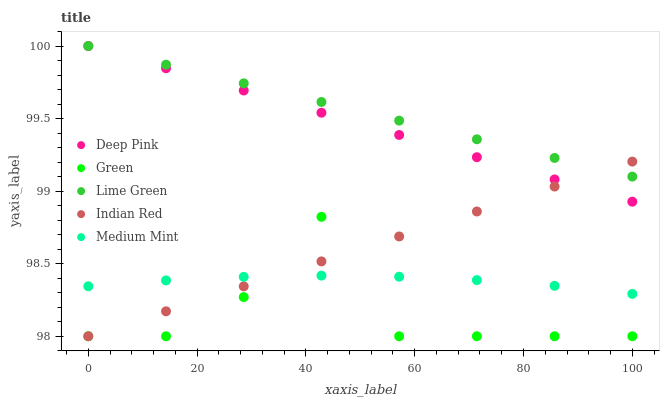Does Green have the minimum area under the curve?
Answer yes or no. Yes. Does Lime Green have the maximum area under the curve?
Answer yes or no. Yes. Does Deep Pink have the minimum area under the curve?
Answer yes or no. No. Does Deep Pink have the maximum area under the curve?
Answer yes or no. No. Is Deep Pink the smoothest?
Answer yes or no. Yes. Is Green the roughest?
Answer yes or no. Yes. Is Lime Green the smoothest?
Answer yes or no. No. Is Lime Green the roughest?
Answer yes or no. No. Does Green have the lowest value?
Answer yes or no. Yes. Does Deep Pink have the lowest value?
Answer yes or no. No. Does Deep Pink have the highest value?
Answer yes or no. Yes. Does Green have the highest value?
Answer yes or no. No. Is Medium Mint less than Deep Pink?
Answer yes or no. Yes. Is Lime Green greater than Medium Mint?
Answer yes or no. Yes. Does Lime Green intersect Deep Pink?
Answer yes or no. Yes. Is Lime Green less than Deep Pink?
Answer yes or no. No. Is Lime Green greater than Deep Pink?
Answer yes or no. No. Does Medium Mint intersect Deep Pink?
Answer yes or no. No. 